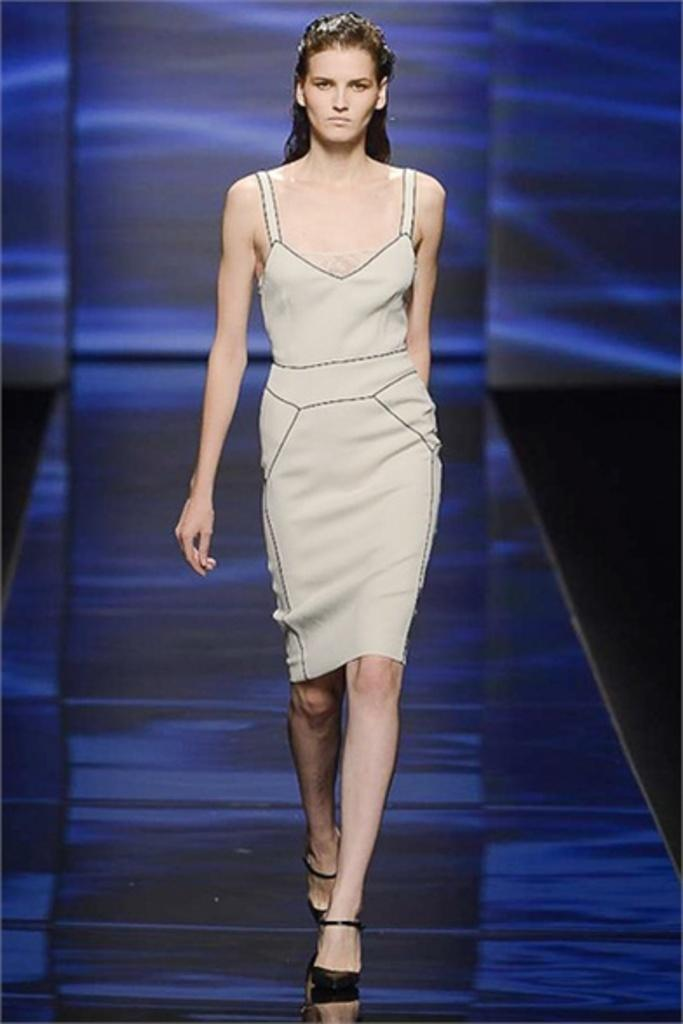Who is present in the image? There is a woman in the image. What is the woman doing in the image? The woman is on a ramp. What can be seen in the background of the image? There is a wall in the background of the image. What type of lighting is present in the image? There are lights on the ramp and on the wall. What health advice is the woman giving in the image? There is no indication in the image that the woman is giving health advice or any suggestions. 